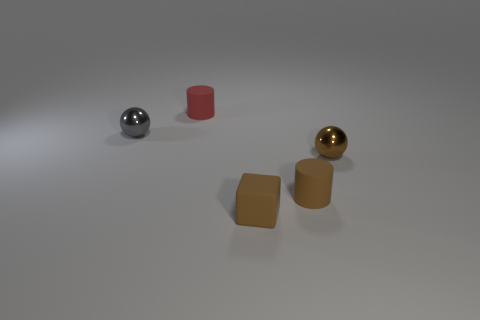Add 4 tiny red matte blocks. How many objects exist? 9 Subtract all spheres. How many objects are left? 3 Add 1 matte objects. How many matte objects are left? 4 Add 2 brown matte cubes. How many brown matte cubes exist? 3 Subtract 0 cyan blocks. How many objects are left? 5 Subtract all large purple spheres. Subtract all cylinders. How many objects are left? 3 